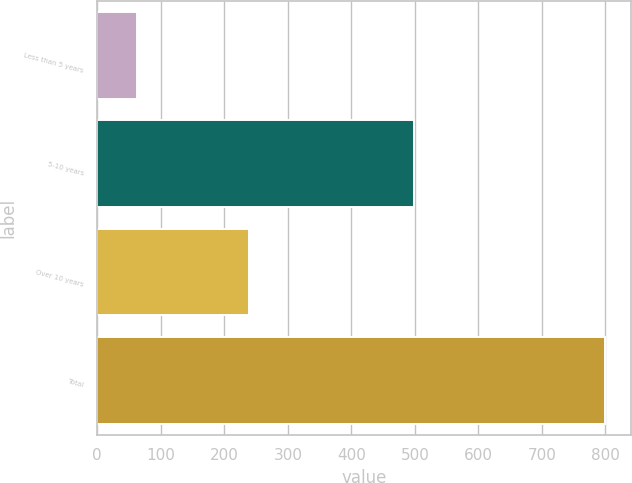<chart> <loc_0><loc_0><loc_500><loc_500><bar_chart><fcel>Less than 5 years<fcel>5-10 years<fcel>Over 10 years<fcel>Total<nl><fcel>62<fcel>499<fcel>239<fcel>800<nl></chart> 